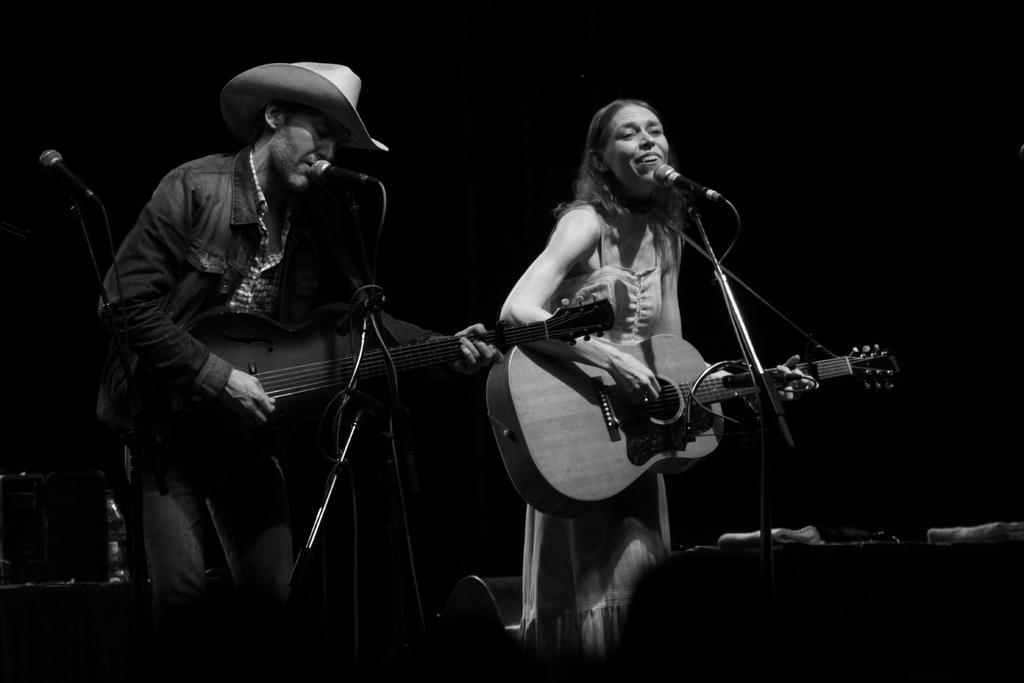In one or two sentences, can you explain what this image depicts? In this image we have a woman standing and playing a guitar near a micro phone , another man standing and playing a guitar and singing a song in the microphone. 